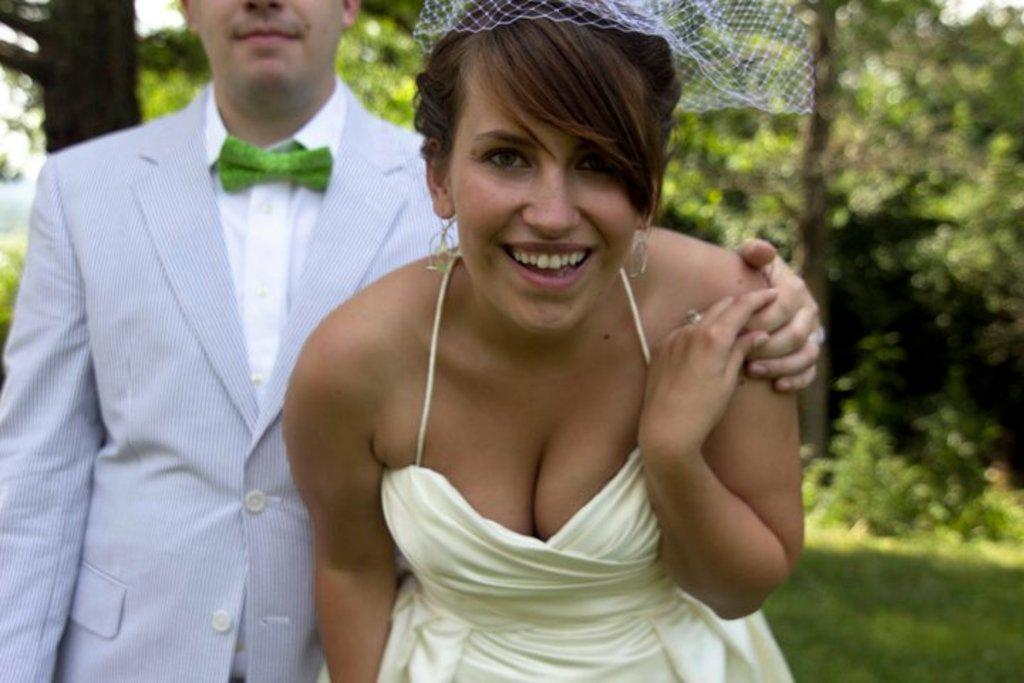Who is present in the image? There is a man and a woman in the image. What is the woman doing in the image? The woman is smiling in the image. What is the woman wearing in the image? The woman is wearing a white dress in the image. What can be seen in the background of the image? There are trees in the background of the image. What type of card is the woman holding in the image? There is no card present in the image. What industry is depicted in the background of the image? There is no industry visible in the image; only trees can be seen in the background. 